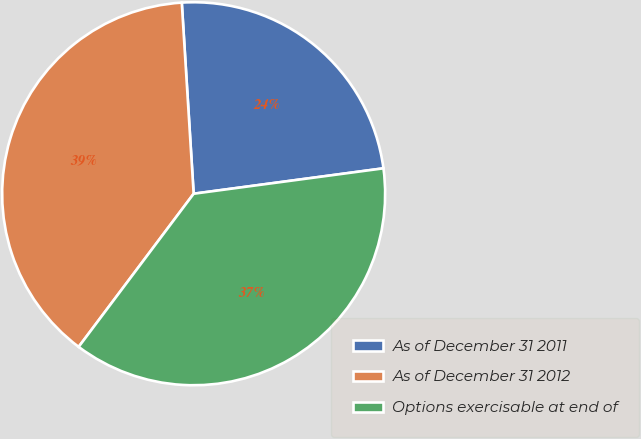<chart> <loc_0><loc_0><loc_500><loc_500><pie_chart><fcel>As of December 31 2011<fcel>As of December 31 2012<fcel>Options exercisable at end of<nl><fcel>23.87%<fcel>38.76%<fcel>37.37%<nl></chart> 